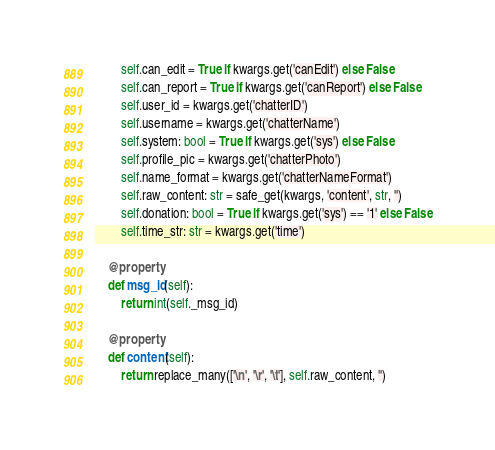Convert code to text. <code><loc_0><loc_0><loc_500><loc_500><_Python_>        self.can_edit = True if kwargs.get('canEdit') else False
        self.can_report = True if kwargs.get('canReport') else False
        self.user_id = kwargs.get('chatterID')
        self.username = kwargs.get('chatterName')
        self.system: bool = True if kwargs.get('sys') else False
        self.profile_pic = kwargs.get('chatterPhoto')
        self.name_format = kwargs.get('chatterNameFormat')
        self.raw_content: str = safe_get(kwargs, 'content', str, '')
        self.donation: bool = True if kwargs.get('sys') == '1' else False
        self.time_str: str = kwargs.get('time')

    @property
    def msg_id(self):
        return int(self._msg_id)

    @property
    def content(self):
        return replace_many(['\n', '\r', '\t'], self.raw_content, '')
</code> 